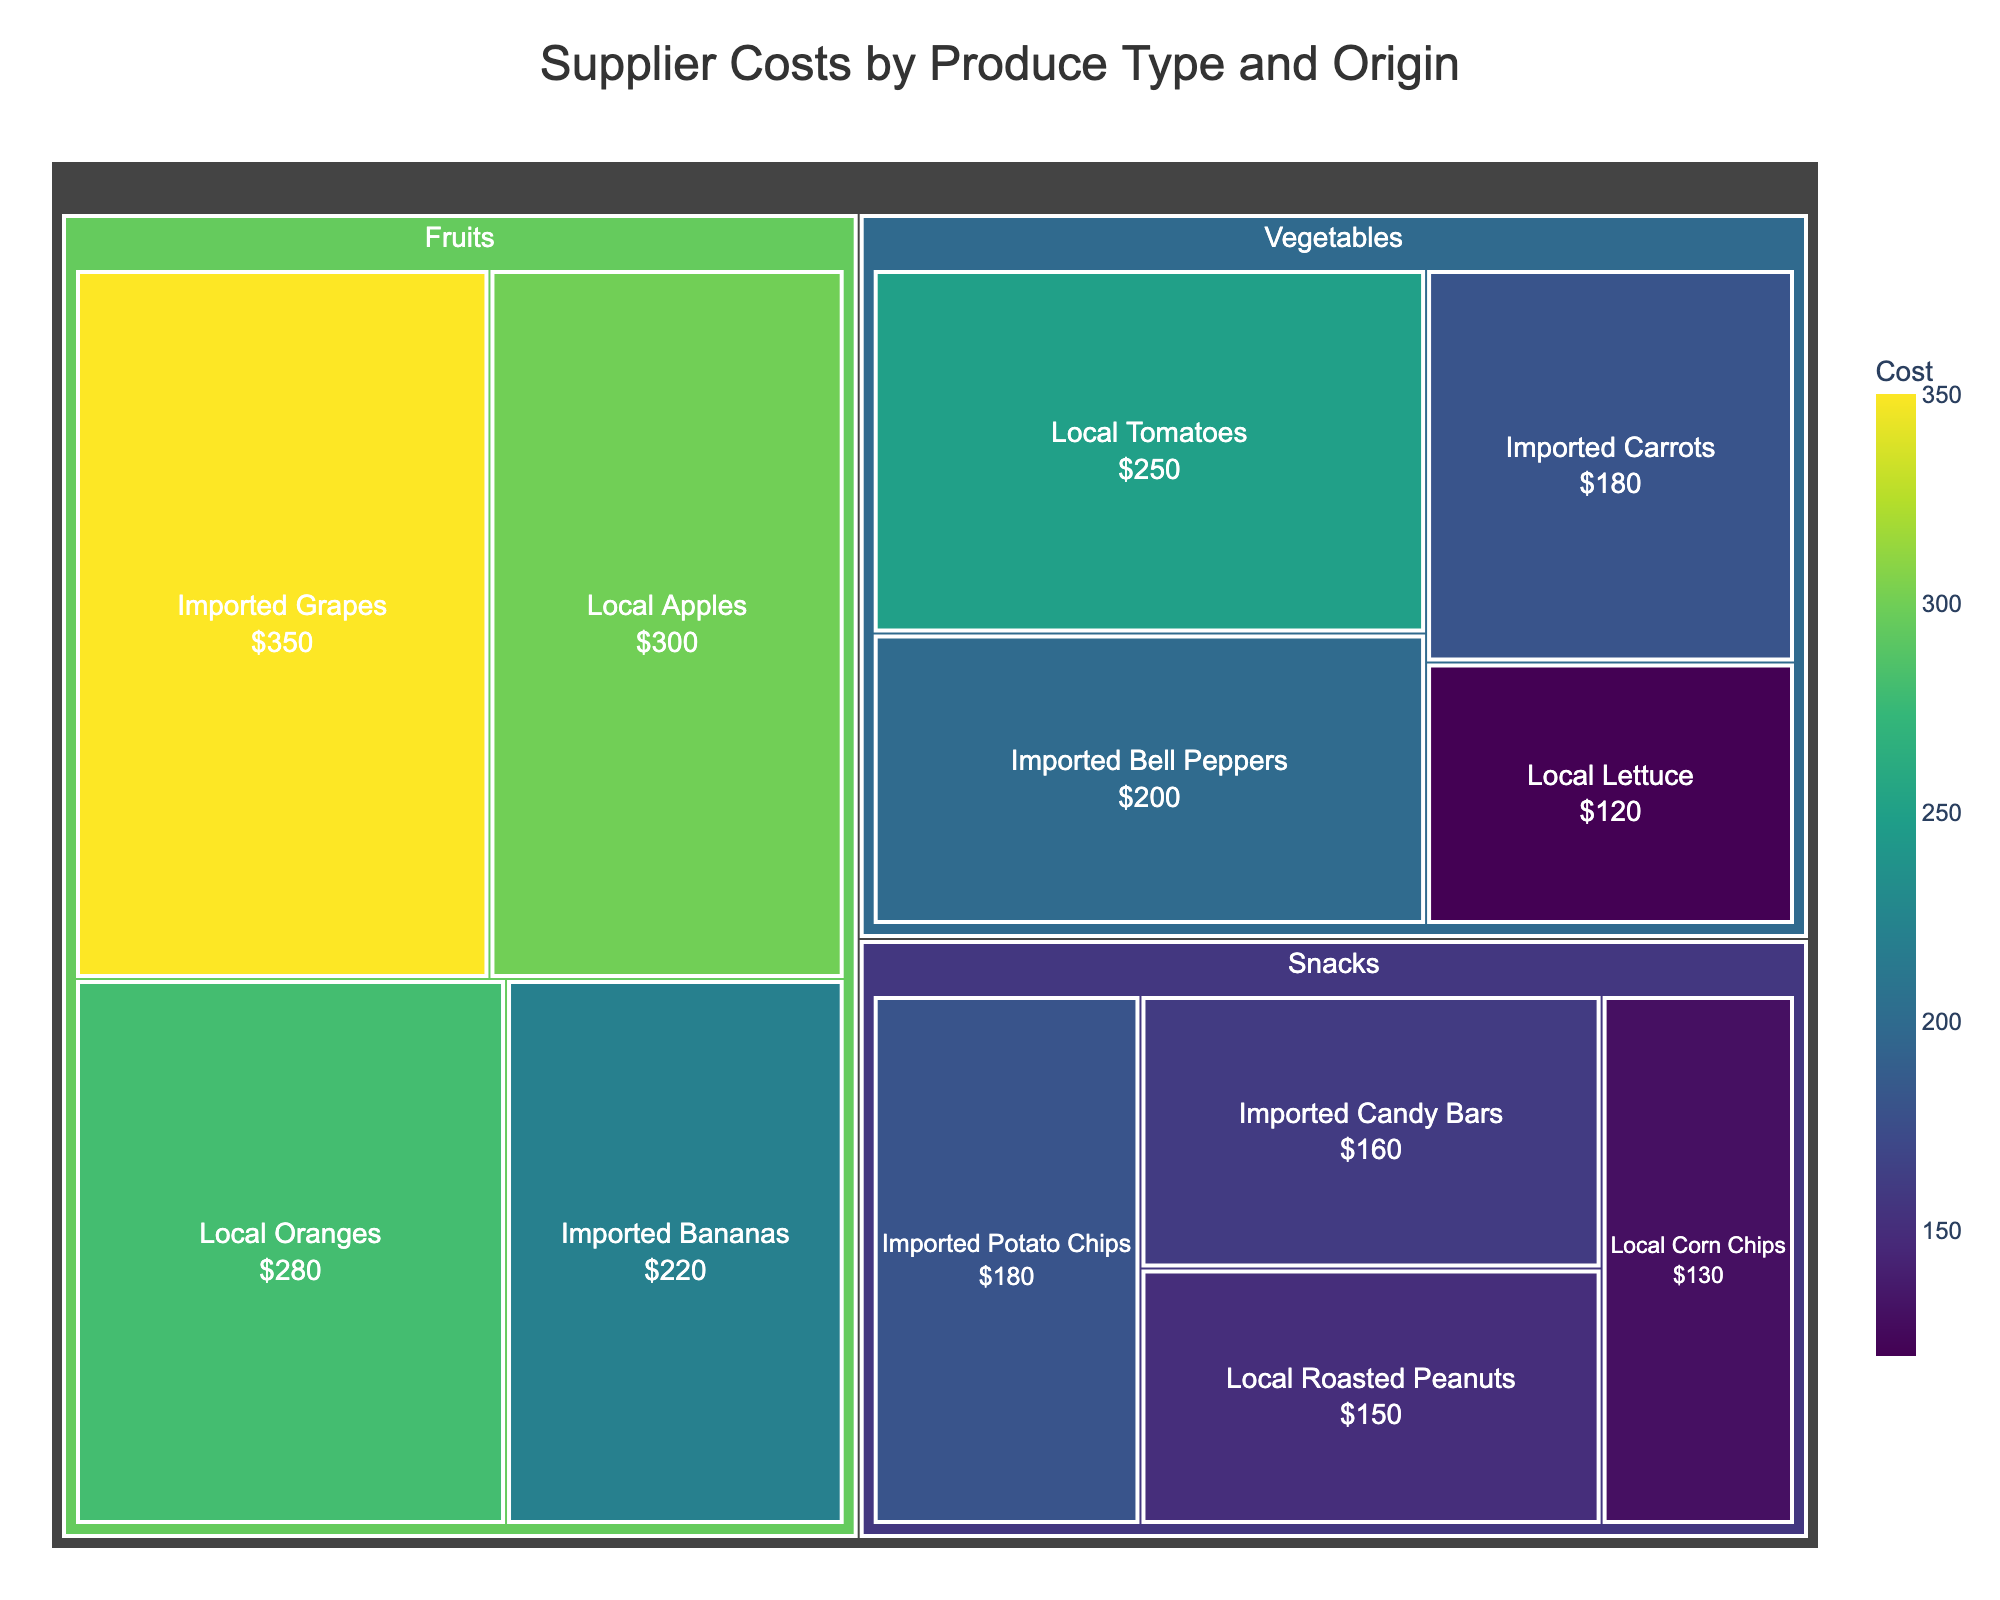Which subcategory has the highest supplier cost? Look for the subcategory with the largest box or the highest value indicated within the Treemap. "Imported Grapes" has the highest cost.
Answer: Imported Grapes What's the total cost for all Fruits? Sum the costs assigned to both local and imported categories under Fruits: Local Apples (300) + Imported Bananas (220) + Local Oranges (280) + Imported Grapes (350). The total is 300 + 220 + 280 + 350 = 1150.
Answer: 1150 Are local or imported Snacks more expensive on average? First, find the average cost for local and imported Snacks. Local Snacks are Roasted Peanuts (150) + Corn Chips (130); average is (150+130)/2 = 140. Imported Snacks are Potato Chips (180) + Candy Bars (160); average is (180+160)/2 = 170. Since 170 is greater than 140, imported Snacks are more expensive on average.
Answer: Imported Snacks Which category, Fruits or Vegetables, has a higher total supplier cost? Sum the costs for all Fruits and all Vegetables. Total Fruits cost is 1150, and total Vegetables cost is Local Tomatoes (250) + Imported Carrots (180) + Local Lettuce (120) + Imported Bell Peppers (200) = 750. Since 1150 > 750, Fruits have a higher total supplier cost.
Answer: Fruits What is the difference in cost between Local Apples and Imported Carrots? Subtract the cost of Imported Carrots (180) from Local Apples (300). The difference is 300 - 180 = 120.
Answer: 120 Which has a lower supplier cost, Local Lettuce or Imported Bananas? Compare the costs directly. Local Lettuce costs 120 while Imported Bananas cost 220. Since 120 < 220, Local Lettuce has a lower cost.
Answer: Local Lettuce What percentage of the total cost is contributed by Imported Bell Peppers? First, calculate the total cost of all categories: 250 + 180 + 120 + 200 + 300 + 220 + 280 + 350 + 150 + 180 + 130 + 160 = 2520. Then, find the percentage contribution of Imported Bell Peppers (200). The percentage is (200/2520) * 100 ≈ 7.94%.
Answer: 7.94% How much more expensive are Imported Grapes compared to Local Roasted Peanuts? Subtract the cost of Local Roasted Peanuts (150) from Imported Grapes (350). The difference is 350 - 150 = 200.
Answer: 200 